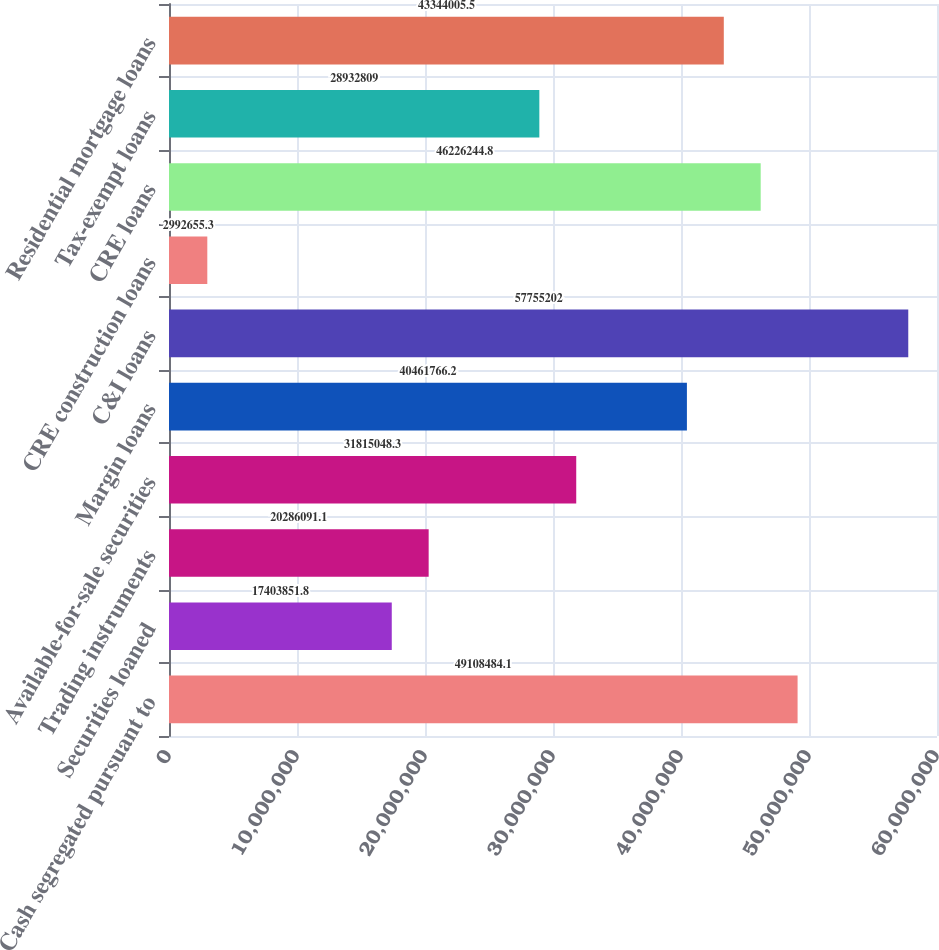Convert chart. <chart><loc_0><loc_0><loc_500><loc_500><bar_chart><fcel>Cash segregated pursuant to<fcel>Securities loaned<fcel>Trading instruments<fcel>Available-for-sale securities<fcel>Margin loans<fcel>C&I loans<fcel>CRE construction loans<fcel>CRE loans<fcel>Tax-exempt loans<fcel>Residential mortgage loans<nl><fcel>4.91085e+07<fcel>1.74039e+07<fcel>2.02861e+07<fcel>3.1815e+07<fcel>4.04618e+07<fcel>5.77552e+07<fcel>2.99266e+06<fcel>4.62262e+07<fcel>2.89328e+07<fcel>4.3344e+07<nl></chart> 